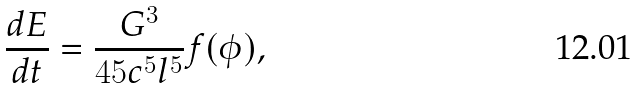<formula> <loc_0><loc_0><loc_500><loc_500>\frac { d E } { d t } = \frac { G ^ { 3 } } { 4 5 c ^ { 5 } l ^ { 5 } } f ( \phi ) ,</formula> 